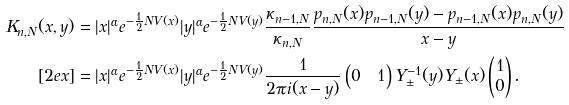Convert formula to latex. <formula><loc_0><loc_0><loc_500><loc_500>K _ { n , N } ( x , y ) & = | x | ^ { \alpha } e ^ { - \frac { 1 } { 2 } N V ( x ) } | y | ^ { \alpha } e ^ { - \frac { 1 } { 2 } N V ( y ) } \frac { \kappa _ { n - 1 , N } } { \kappa _ { n , N } } \frac { p _ { n , N } ( x ) p _ { n - 1 , N } ( y ) - p _ { n - 1 , N } ( x ) p _ { n , N } ( y ) } { x - y } \\ [ 2 e x ] & = | x | ^ { \alpha } e ^ { - \frac { 1 } { 2 } N V ( x ) } | y | ^ { \alpha } e ^ { - \frac { 1 } { 2 } N V ( y ) } \frac { 1 } { 2 \pi i ( x - y ) } \begin{pmatrix} 0 & 1 \end{pmatrix} Y _ { \pm } ^ { - 1 } ( y ) Y _ { \pm } ( x ) \begin{pmatrix} 1 \\ 0 \end{pmatrix} .</formula> 